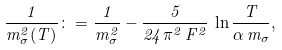Convert formula to latex. <formula><loc_0><loc_0><loc_500><loc_500>\frac { 1 } { m ^ { 2 } _ { \sigma } ( T ) } \colon = \frac { 1 } { m ^ { 2 } _ { \sigma } } - \frac { 5 } { 2 4 \pi ^ { 2 } \, F ^ { 2 } } \, \ln \frac { T } { \alpha \, m _ { \sigma } } ,</formula> 